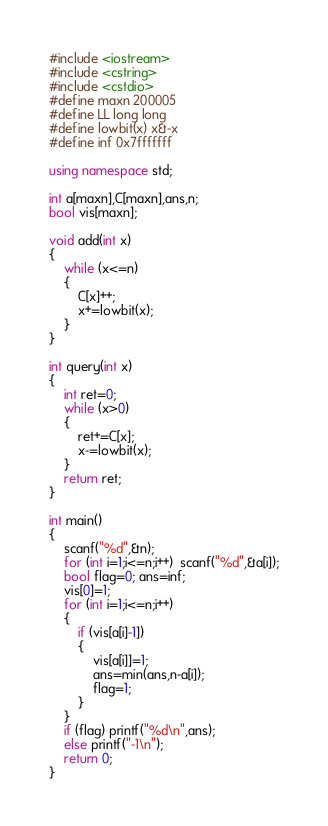Convert code to text. <code><loc_0><loc_0><loc_500><loc_500><_C++_>#include <iostream>
#include <cstring>
#include <cstdio>
#define maxn 200005
#define LL long long
#define lowbit(x) x&-x
#define inf 0x7fffffff

using namespace std;

int a[maxn],C[maxn],ans,n;
bool vis[maxn];

void add(int x)
{
    while (x<=n)
    {
        C[x]++;
        x+=lowbit(x);
    }
}

int query(int x)
{
    int ret=0;
    while (x>0)
    {
        ret+=C[x];
        x-=lowbit(x);
    }
    return ret;
}

int main()
{
    scanf("%d",&n);
    for (int i=1;i<=n;i++)  scanf("%d",&a[i]);
    bool flag=0; ans=inf;
    vis[0]=1;
    for (int i=1;i<=n;i++)
    {
        if (vis[a[i]-1])
        {
            vis[a[i]]=1;
            ans=min(ans,n-a[i]);
            flag=1;
        }
    }
    if (flag) printf("%d\n",ans);
    else printf("-1\n");
    return 0;
}
</code> 